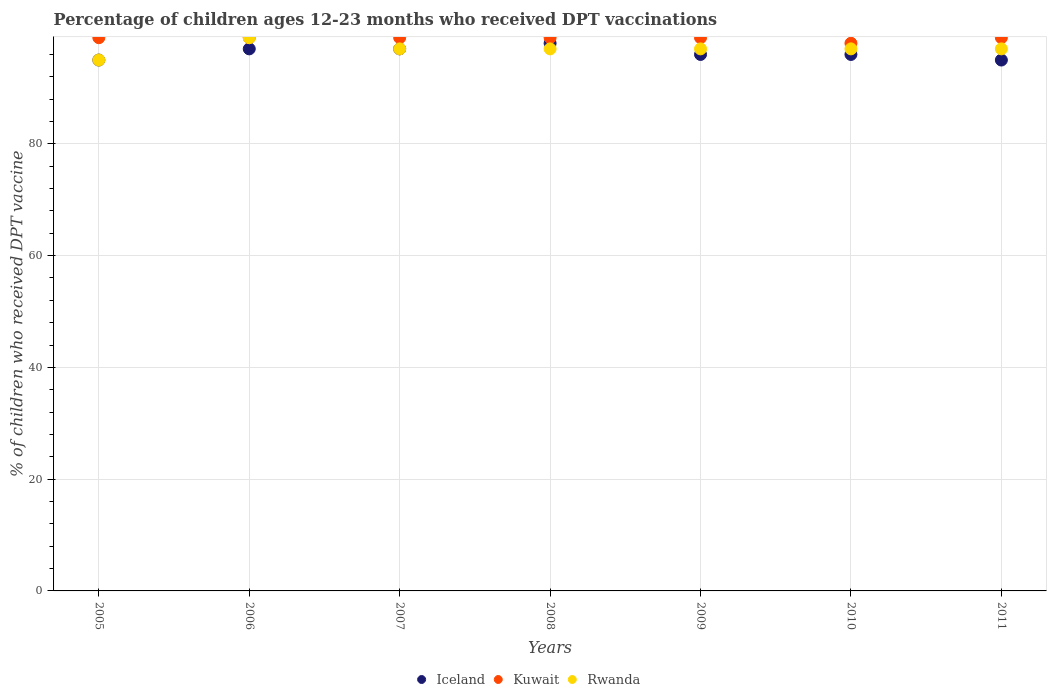How many different coloured dotlines are there?
Keep it short and to the point. 3. What is the percentage of children who received DPT vaccination in Kuwait in 2009?
Make the answer very short. 99. Across all years, what is the maximum percentage of children who received DPT vaccination in Iceland?
Provide a succinct answer. 98. Across all years, what is the minimum percentage of children who received DPT vaccination in Kuwait?
Your answer should be very brief. 98. In which year was the percentage of children who received DPT vaccination in Iceland maximum?
Ensure brevity in your answer.  2008. In which year was the percentage of children who received DPT vaccination in Kuwait minimum?
Provide a short and direct response. 2010. What is the total percentage of children who received DPT vaccination in Kuwait in the graph?
Your response must be concise. 692. What is the difference between the percentage of children who received DPT vaccination in Iceland in 2006 and that in 2011?
Your answer should be compact. 2. What is the difference between the percentage of children who received DPT vaccination in Kuwait in 2007 and the percentage of children who received DPT vaccination in Rwanda in 2008?
Keep it short and to the point. 2. What is the average percentage of children who received DPT vaccination in Kuwait per year?
Make the answer very short. 98.86. What is the ratio of the percentage of children who received DPT vaccination in Iceland in 2005 to that in 2007?
Your answer should be compact. 0.98. Is the percentage of children who received DPT vaccination in Rwanda in 2007 less than that in 2010?
Keep it short and to the point. No. What is the difference between the highest and the second highest percentage of children who received DPT vaccination in Rwanda?
Your answer should be compact. 2. What is the difference between the highest and the lowest percentage of children who received DPT vaccination in Kuwait?
Provide a succinct answer. 1. In how many years, is the percentage of children who received DPT vaccination in Kuwait greater than the average percentage of children who received DPT vaccination in Kuwait taken over all years?
Offer a terse response. 6. Is the sum of the percentage of children who received DPT vaccination in Rwanda in 2007 and 2011 greater than the maximum percentage of children who received DPT vaccination in Iceland across all years?
Your response must be concise. Yes. Is the percentage of children who received DPT vaccination in Rwanda strictly greater than the percentage of children who received DPT vaccination in Iceland over the years?
Your answer should be compact. No. Is the percentage of children who received DPT vaccination in Kuwait strictly less than the percentage of children who received DPT vaccination in Rwanda over the years?
Your answer should be very brief. No. How many dotlines are there?
Provide a short and direct response. 3. How many years are there in the graph?
Provide a succinct answer. 7. Are the values on the major ticks of Y-axis written in scientific E-notation?
Provide a succinct answer. No. Where does the legend appear in the graph?
Keep it short and to the point. Bottom center. How many legend labels are there?
Give a very brief answer. 3. How are the legend labels stacked?
Offer a very short reply. Horizontal. What is the title of the graph?
Your answer should be very brief. Percentage of children ages 12-23 months who received DPT vaccinations. Does "Angola" appear as one of the legend labels in the graph?
Keep it short and to the point. No. What is the label or title of the X-axis?
Your answer should be compact. Years. What is the label or title of the Y-axis?
Provide a short and direct response. % of children who received DPT vaccine. What is the % of children who received DPT vaccine in Iceland in 2006?
Your answer should be very brief. 97. What is the % of children who received DPT vaccine of Rwanda in 2006?
Make the answer very short. 99. What is the % of children who received DPT vaccine of Iceland in 2007?
Provide a succinct answer. 97. What is the % of children who received DPT vaccine in Kuwait in 2007?
Keep it short and to the point. 99. What is the % of children who received DPT vaccine in Rwanda in 2007?
Ensure brevity in your answer.  97. What is the % of children who received DPT vaccine in Iceland in 2008?
Offer a terse response. 98. What is the % of children who received DPT vaccine in Kuwait in 2008?
Keep it short and to the point. 99. What is the % of children who received DPT vaccine in Rwanda in 2008?
Offer a very short reply. 97. What is the % of children who received DPT vaccine in Iceland in 2009?
Provide a succinct answer. 96. What is the % of children who received DPT vaccine of Rwanda in 2009?
Give a very brief answer. 97. What is the % of children who received DPT vaccine in Iceland in 2010?
Keep it short and to the point. 96. What is the % of children who received DPT vaccine in Kuwait in 2010?
Provide a succinct answer. 98. What is the % of children who received DPT vaccine of Rwanda in 2010?
Give a very brief answer. 97. What is the % of children who received DPT vaccine of Iceland in 2011?
Your answer should be compact. 95. What is the % of children who received DPT vaccine in Rwanda in 2011?
Provide a short and direct response. 97. Across all years, what is the maximum % of children who received DPT vaccine in Kuwait?
Make the answer very short. 99. Across all years, what is the maximum % of children who received DPT vaccine in Rwanda?
Your response must be concise. 99. What is the total % of children who received DPT vaccine of Iceland in the graph?
Your response must be concise. 674. What is the total % of children who received DPT vaccine in Kuwait in the graph?
Make the answer very short. 692. What is the total % of children who received DPT vaccine in Rwanda in the graph?
Ensure brevity in your answer.  679. What is the difference between the % of children who received DPT vaccine of Iceland in 2005 and that in 2006?
Give a very brief answer. -2. What is the difference between the % of children who received DPT vaccine of Iceland in 2005 and that in 2007?
Keep it short and to the point. -2. What is the difference between the % of children who received DPT vaccine in Rwanda in 2005 and that in 2007?
Keep it short and to the point. -2. What is the difference between the % of children who received DPT vaccine in Iceland in 2005 and that in 2008?
Your answer should be very brief. -3. What is the difference between the % of children who received DPT vaccine in Kuwait in 2005 and that in 2008?
Provide a short and direct response. 0. What is the difference between the % of children who received DPT vaccine in Iceland in 2005 and that in 2009?
Give a very brief answer. -1. What is the difference between the % of children who received DPT vaccine of Iceland in 2005 and that in 2010?
Keep it short and to the point. -1. What is the difference between the % of children who received DPT vaccine of Kuwait in 2005 and that in 2010?
Keep it short and to the point. 1. What is the difference between the % of children who received DPT vaccine of Rwanda in 2005 and that in 2010?
Your answer should be very brief. -2. What is the difference between the % of children who received DPT vaccine of Iceland in 2005 and that in 2011?
Provide a short and direct response. 0. What is the difference between the % of children who received DPT vaccine of Rwanda in 2005 and that in 2011?
Give a very brief answer. -2. What is the difference between the % of children who received DPT vaccine of Iceland in 2006 and that in 2007?
Your response must be concise. 0. What is the difference between the % of children who received DPT vaccine in Kuwait in 2006 and that in 2007?
Give a very brief answer. 0. What is the difference between the % of children who received DPT vaccine of Iceland in 2006 and that in 2008?
Ensure brevity in your answer.  -1. What is the difference between the % of children who received DPT vaccine in Kuwait in 2006 and that in 2008?
Provide a succinct answer. 0. What is the difference between the % of children who received DPT vaccine in Kuwait in 2006 and that in 2009?
Make the answer very short. 0. What is the difference between the % of children who received DPT vaccine in Kuwait in 2006 and that in 2010?
Make the answer very short. 1. What is the difference between the % of children who received DPT vaccine in Iceland in 2006 and that in 2011?
Provide a succinct answer. 2. What is the difference between the % of children who received DPT vaccine in Rwanda in 2006 and that in 2011?
Offer a very short reply. 2. What is the difference between the % of children who received DPT vaccine of Kuwait in 2007 and that in 2008?
Provide a short and direct response. 0. What is the difference between the % of children who received DPT vaccine in Rwanda in 2007 and that in 2008?
Give a very brief answer. 0. What is the difference between the % of children who received DPT vaccine in Kuwait in 2007 and that in 2010?
Your answer should be very brief. 1. What is the difference between the % of children who received DPT vaccine in Rwanda in 2007 and that in 2011?
Provide a succinct answer. 0. What is the difference between the % of children who received DPT vaccine of Iceland in 2008 and that in 2009?
Keep it short and to the point. 2. What is the difference between the % of children who received DPT vaccine of Kuwait in 2008 and that in 2009?
Give a very brief answer. 0. What is the difference between the % of children who received DPT vaccine in Rwanda in 2008 and that in 2009?
Your answer should be very brief. 0. What is the difference between the % of children who received DPT vaccine of Iceland in 2008 and that in 2010?
Offer a terse response. 2. What is the difference between the % of children who received DPT vaccine in Rwanda in 2008 and that in 2010?
Your response must be concise. 0. What is the difference between the % of children who received DPT vaccine of Kuwait in 2008 and that in 2011?
Make the answer very short. 0. What is the difference between the % of children who received DPT vaccine of Rwanda in 2008 and that in 2011?
Give a very brief answer. 0. What is the difference between the % of children who received DPT vaccine in Kuwait in 2009 and that in 2010?
Provide a short and direct response. 1. What is the difference between the % of children who received DPT vaccine of Kuwait in 2009 and that in 2011?
Give a very brief answer. 0. What is the difference between the % of children who received DPT vaccine in Iceland in 2010 and that in 2011?
Your answer should be very brief. 1. What is the difference between the % of children who received DPT vaccine in Kuwait in 2010 and that in 2011?
Make the answer very short. -1. What is the difference between the % of children who received DPT vaccine in Iceland in 2005 and the % of children who received DPT vaccine in Rwanda in 2006?
Give a very brief answer. -4. What is the difference between the % of children who received DPT vaccine of Kuwait in 2005 and the % of children who received DPT vaccine of Rwanda in 2006?
Keep it short and to the point. 0. What is the difference between the % of children who received DPT vaccine in Iceland in 2005 and the % of children who received DPT vaccine in Rwanda in 2007?
Provide a short and direct response. -2. What is the difference between the % of children who received DPT vaccine in Kuwait in 2005 and the % of children who received DPT vaccine in Rwanda in 2007?
Offer a terse response. 2. What is the difference between the % of children who received DPT vaccine in Iceland in 2005 and the % of children who received DPT vaccine in Kuwait in 2008?
Offer a terse response. -4. What is the difference between the % of children who received DPT vaccine in Iceland in 2005 and the % of children who received DPT vaccine in Kuwait in 2010?
Keep it short and to the point. -3. What is the difference between the % of children who received DPT vaccine in Kuwait in 2005 and the % of children who received DPT vaccine in Rwanda in 2010?
Offer a very short reply. 2. What is the difference between the % of children who received DPT vaccine in Iceland in 2005 and the % of children who received DPT vaccine in Rwanda in 2011?
Make the answer very short. -2. What is the difference between the % of children who received DPT vaccine of Kuwait in 2005 and the % of children who received DPT vaccine of Rwanda in 2011?
Make the answer very short. 2. What is the difference between the % of children who received DPT vaccine in Iceland in 2006 and the % of children who received DPT vaccine in Rwanda in 2007?
Give a very brief answer. 0. What is the difference between the % of children who received DPT vaccine in Iceland in 2006 and the % of children who received DPT vaccine in Kuwait in 2008?
Provide a succinct answer. -2. What is the difference between the % of children who received DPT vaccine of Iceland in 2006 and the % of children who received DPT vaccine of Kuwait in 2009?
Offer a terse response. -2. What is the difference between the % of children who received DPT vaccine in Iceland in 2006 and the % of children who received DPT vaccine in Kuwait in 2010?
Provide a short and direct response. -1. What is the difference between the % of children who received DPT vaccine of Kuwait in 2006 and the % of children who received DPT vaccine of Rwanda in 2010?
Give a very brief answer. 2. What is the difference between the % of children who received DPT vaccine in Iceland in 2006 and the % of children who received DPT vaccine in Kuwait in 2011?
Give a very brief answer. -2. What is the difference between the % of children who received DPT vaccine of Iceland in 2006 and the % of children who received DPT vaccine of Rwanda in 2011?
Provide a short and direct response. 0. What is the difference between the % of children who received DPT vaccine in Kuwait in 2006 and the % of children who received DPT vaccine in Rwanda in 2011?
Offer a very short reply. 2. What is the difference between the % of children who received DPT vaccine of Kuwait in 2007 and the % of children who received DPT vaccine of Rwanda in 2009?
Your response must be concise. 2. What is the difference between the % of children who received DPT vaccine of Iceland in 2007 and the % of children who received DPT vaccine of Kuwait in 2010?
Your answer should be compact. -1. What is the difference between the % of children who received DPT vaccine of Iceland in 2007 and the % of children who received DPT vaccine of Rwanda in 2010?
Your answer should be very brief. 0. What is the difference between the % of children who received DPT vaccine of Kuwait in 2007 and the % of children who received DPT vaccine of Rwanda in 2010?
Provide a succinct answer. 2. What is the difference between the % of children who received DPT vaccine of Iceland in 2007 and the % of children who received DPT vaccine of Kuwait in 2011?
Make the answer very short. -2. What is the difference between the % of children who received DPT vaccine in Iceland in 2008 and the % of children who received DPT vaccine in Rwanda in 2009?
Offer a very short reply. 1. What is the difference between the % of children who received DPT vaccine in Iceland in 2008 and the % of children who received DPT vaccine in Kuwait in 2010?
Offer a very short reply. 0. What is the difference between the % of children who received DPT vaccine in Iceland in 2008 and the % of children who received DPT vaccine in Rwanda in 2011?
Your answer should be compact. 1. What is the difference between the % of children who received DPT vaccine in Iceland in 2009 and the % of children who received DPT vaccine in Kuwait in 2010?
Offer a terse response. -2. What is the difference between the % of children who received DPT vaccine in Iceland in 2009 and the % of children who received DPT vaccine in Kuwait in 2011?
Your response must be concise. -3. What is the difference between the % of children who received DPT vaccine in Iceland in 2010 and the % of children who received DPT vaccine in Rwanda in 2011?
Ensure brevity in your answer.  -1. What is the average % of children who received DPT vaccine of Iceland per year?
Provide a succinct answer. 96.29. What is the average % of children who received DPT vaccine of Kuwait per year?
Your answer should be compact. 98.86. What is the average % of children who received DPT vaccine in Rwanda per year?
Offer a very short reply. 97. In the year 2005, what is the difference between the % of children who received DPT vaccine of Kuwait and % of children who received DPT vaccine of Rwanda?
Give a very brief answer. 4. In the year 2007, what is the difference between the % of children who received DPT vaccine in Iceland and % of children who received DPT vaccine in Kuwait?
Provide a short and direct response. -2. In the year 2007, what is the difference between the % of children who received DPT vaccine of Iceland and % of children who received DPT vaccine of Rwanda?
Your answer should be very brief. 0. In the year 2007, what is the difference between the % of children who received DPT vaccine of Kuwait and % of children who received DPT vaccine of Rwanda?
Ensure brevity in your answer.  2. In the year 2008, what is the difference between the % of children who received DPT vaccine in Iceland and % of children who received DPT vaccine in Kuwait?
Your response must be concise. -1. In the year 2008, what is the difference between the % of children who received DPT vaccine in Iceland and % of children who received DPT vaccine in Rwanda?
Keep it short and to the point. 1. In the year 2009, what is the difference between the % of children who received DPT vaccine in Iceland and % of children who received DPT vaccine in Kuwait?
Give a very brief answer. -3. In the year 2009, what is the difference between the % of children who received DPT vaccine of Iceland and % of children who received DPT vaccine of Rwanda?
Keep it short and to the point. -1. In the year 2009, what is the difference between the % of children who received DPT vaccine in Kuwait and % of children who received DPT vaccine in Rwanda?
Your answer should be compact. 2. In the year 2010, what is the difference between the % of children who received DPT vaccine in Kuwait and % of children who received DPT vaccine in Rwanda?
Your answer should be compact. 1. In the year 2011, what is the difference between the % of children who received DPT vaccine in Iceland and % of children who received DPT vaccine in Kuwait?
Your response must be concise. -4. In the year 2011, what is the difference between the % of children who received DPT vaccine in Iceland and % of children who received DPT vaccine in Rwanda?
Keep it short and to the point. -2. In the year 2011, what is the difference between the % of children who received DPT vaccine of Kuwait and % of children who received DPT vaccine of Rwanda?
Provide a succinct answer. 2. What is the ratio of the % of children who received DPT vaccine of Iceland in 2005 to that in 2006?
Keep it short and to the point. 0.98. What is the ratio of the % of children who received DPT vaccine of Rwanda in 2005 to that in 2006?
Make the answer very short. 0.96. What is the ratio of the % of children who received DPT vaccine of Iceland in 2005 to that in 2007?
Provide a succinct answer. 0.98. What is the ratio of the % of children who received DPT vaccine in Rwanda in 2005 to that in 2007?
Make the answer very short. 0.98. What is the ratio of the % of children who received DPT vaccine in Iceland in 2005 to that in 2008?
Offer a terse response. 0.97. What is the ratio of the % of children who received DPT vaccine in Kuwait in 2005 to that in 2008?
Your answer should be compact. 1. What is the ratio of the % of children who received DPT vaccine in Rwanda in 2005 to that in 2008?
Your answer should be compact. 0.98. What is the ratio of the % of children who received DPT vaccine of Kuwait in 2005 to that in 2009?
Give a very brief answer. 1. What is the ratio of the % of children who received DPT vaccine of Rwanda in 2005 to that in 2009?
Provide a succinct answer. 0.98. What is the ratio of the % of children who received DPT vaccine in Kuwait in 2005 to that in 2010?
Your answer should be compact. 1.01. What is the ratio of the % of children who received DPT vaccine of Rwanda in 2005 to that in 2010?
Your response must be concise. 0.98. What is the ratio of the % of children who received DPT vaccine in Iceland in 2005 to that in 2011?
Keep it short and to the point. 1. What is the ratio of the % of children who received DPT vaccine of Rwanda in 2005 to that in 2011?
Your answer should be compact. 0.98. What is the ratio of the % of children who received DPT vaccine in Iceland in 2006 to that in 2007?
Your answer should be compact. 1. What is the ratio of the % of children who received DPT vaccine in Kuwait in 2006 to that in 2007?
Give a very brief answer. 1. What is the ratio of the % of children who received DPT vaccine in Rwanda in 2006 to that in 2007?
Your response must be concise. 1.02. What is the ratio of the % of children who received DPT vaccine in Iceland in 2006 to that in 2008?
Give a very brief answer. 0.99. What is the ratio of the % of children who received DPT vaccine of Rwanda in 2006 to that in 2008?
Keep it short and to the point. 1.02. What is the ratio of the % of children who received DPT vaccine of Iceland in 2006 to that in 2009?
Provide a succinct answer. 1.01. What is the ratio of the % of children who received DPT vaccine in Kuwait in 2006 to that in 2009?
Make the answer very short. 1. What is the ratio of the % of children who received DPT vaccine of Rwanda in 2006 to that in 2009?
Provide a succinct answer. 1.02. What is the ratio of the % of children who received DPT vaccine of Iceland in 2006 to that in 2010?
Your answer should be compact. 1.01. What is the ratio of the % of children who received DPT vaccine of Kuwait in 2006 to that in 2010?
Your answer should be very brief. 1.01. What is the ratio of the % of children who received DPT vaccine of Rwanda in 2006 to that in 2010?
Keep it short and to the point. 1.02. What is the ratio of the % of children who received DPT vaccine in Iceland in 2006 to that in 2011?
Keep it short and to the point. 1.02. What is the ratio of the % of children who received DPT vaccine of Kuwait in 2006 to that in 2011?
Your response must be concise. 1. What is the ratio of the % of children who received DPT vaccine of Rwanda in 2006 to that in 2011?
Provide a short and direct response. 1.02. What is the ratio of the % of children who received DPT vaccine of Kuwait in 2007 to that in 2008?
Provide a succinct answer. 1. What is the ratio of the % of children who received DPT vaccine in Iceland in 2007 to that in 2009?
Your answer should be compact. 1.01. What is the ratio of the % of children who received DPT vaccine of Iceland in 2007 to that in 2010?
Keep it short and to the point. 1.01. What is the ratio of the % of children who received DPT vaccine of Kuwait in 2007 to that in 2010?
Offer a terse response. 1.01. What is the ratio of the % of children who received DPT vaccine in Iceland in 2007 to that in 2011?
Provide a short and direct response. 1.02. What is the ratio of the % of children who received DPT vaccine in Kuwait in 2007 to that in 2011?
Provide a short and direct response. 1. What is the ratio of the % of children who received DPT vaccine in Iceland in 2008 to that in 2009?
Ensure brevity in your answer.  1.02. What is the ratio of the % of children who received DPT vaccine in Iceland in 2008 to that in 2010?
Your answer should be compact. 1.02. What is the ratio of the % of children who received DPT vaccine of Kuwait in 2008 to that in 2010?
Ensure brevity in your answer.  1.01. What is the ratio of the % of children who received DPT vaccine in Rwanda in 2008 to that in 2010?
Provide a short and direct response. 1. What is the ratio of the % of children who received DPT vaccine of Iceland in 2008 to that in 2011?
Your answer should be very brief. 1.03. What is the ratio of the % of children who received DPT vaccine of Kuwait in 2008 to that in 2011?
Offer a very short reply. 1. What is the ratio of the % of children who received DPT vaccine in Rwanda in 2008 to that in 2011?
Provide a succinct answer. 1. What is the ratio of the % of children who received DPT vaccine in Iceland in 2009 to that in 2010?
Offer a very short reply. 1. What is the ratio of the % of children who received DPT vaccine of Kuwait in 2009 to that in 2010?
Ensure brevity in your answer.  1.01. What is the ratio of the % of children who received DPT vaccine in Rwanda in 2009 to that in 2010?
Offer a very short reply. 1. What is the ratio of the % of children who received DPT vaccine in Iceland in 2009 to that in 2011?
Make the answer very short. 1.01. What is the ratio of the % of children who received DPT vaccine in Iceland in 2010 to that in 2011?
Ensure brevity in your answer.  1.01. What is the ratio of the % of children who received DPT vaccine in Kuwait in 2010 to that in 2011?
Your response must be concise. 0.99. What is the ratio of the % of children who received DPT vaccine in Rwanda in 2010 to that in 2011?
Your response must be concise. 1. What is the difference between the highest and the second highest % of children who received DPT vaccine in Iceland?
Your response must be concise. 1. What is the difference between the highest and the second highest % of children who received DPT vaccine of Rwanda?
Your answer should be compact. 2. 